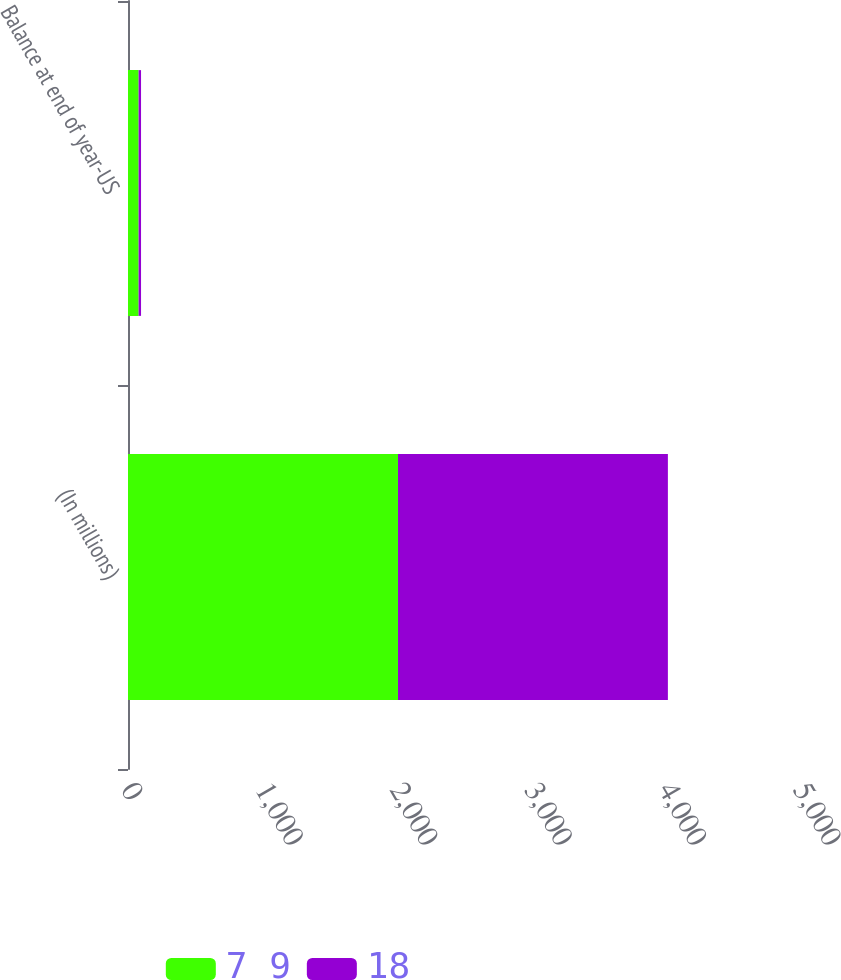Convert chart to OTSL. <chart><loc_0><loc_0><loc_500><loc_500><stacked_bar_chart><ecel><fcel>(In millions)<fcel>Balance at end of year-US<nl><fcel>7 9<fcel>2009<fcel>79<nl><fcel>18<fcel>2008<fcel>18<nl></chart> 